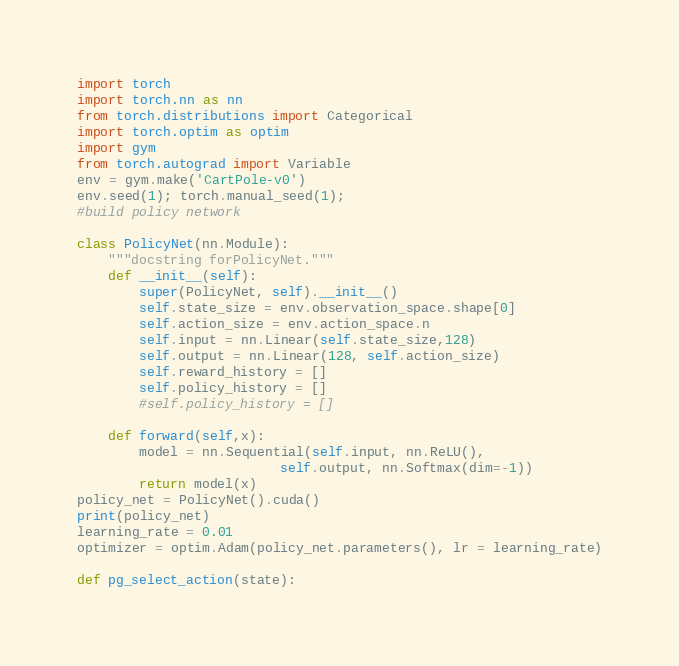Convert code to text. <code><loc_0><loc_0><loc_500><loc_500><_Python_>import torch
import torch.nn as nn
from torch.distributions import Categorical
import torch.optim as optim
import gym
from torch.autograd import Variable
env = gym.make('CartPole-v0')
env.seed(1); torch.manual_seed(1);
#build policy network

class PolicyNet(nn.Module):
    """docstring forPolicyNet."""
    def __init__(self):
        super(PolicyNet, self).__init__()
        self.state_size = env.observation_space.shape[0]
        self.action_size = env.action_space.n
        self.input = nn.Linear(self.state_size,128)
        self.output = nn.Linear(128, self.action_size)
        self.reward_history = []
        self.policy_history = []
        #self.policy_history = []

    def forward(self,x):
        model = nn.Sequential(self.input, nn.ReLU(),
                          self.output, nn.Softmax(dim=-1))
        return model(x)
policy_net = PolicyNet().cuda()
print(policy_net)
learning_rate = 0.01
optimizer = optim.Adam(policy_net.parameters(), lr = learning_rate)

def pg_select_action(state):</code> 